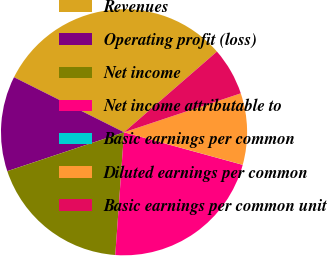Convert chart to OTSL. <chart><loc_0><loc_0><loc_500><loc_500><pie_chart><fcel>Revenues<fcel>Operating profit (loss)<fcel>Net income<fcel>Net income attributable to<fcel>Basic earnings per common<fcel>Diluted earnings per common<fcel>Basic earnings per common unit<nl><fcel>31.24%<fcel>12.5%<fcel>18.75%<fcel>21.87%<fcel>0.01%<fcel>9.38%<fcel>6.26%<nl></chart> 